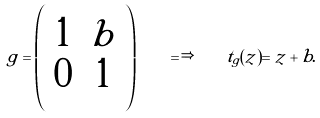Convert formula to latex. <formula><loc_0><loc_0><loc_500><loc_500>g = \left ( \begin{array} { c c } 1 & b \\ 0 & 1 \end{array} \right ) \quad \Longrightarrow \quad t _ { g } ( z ) = z + b .</formula> 